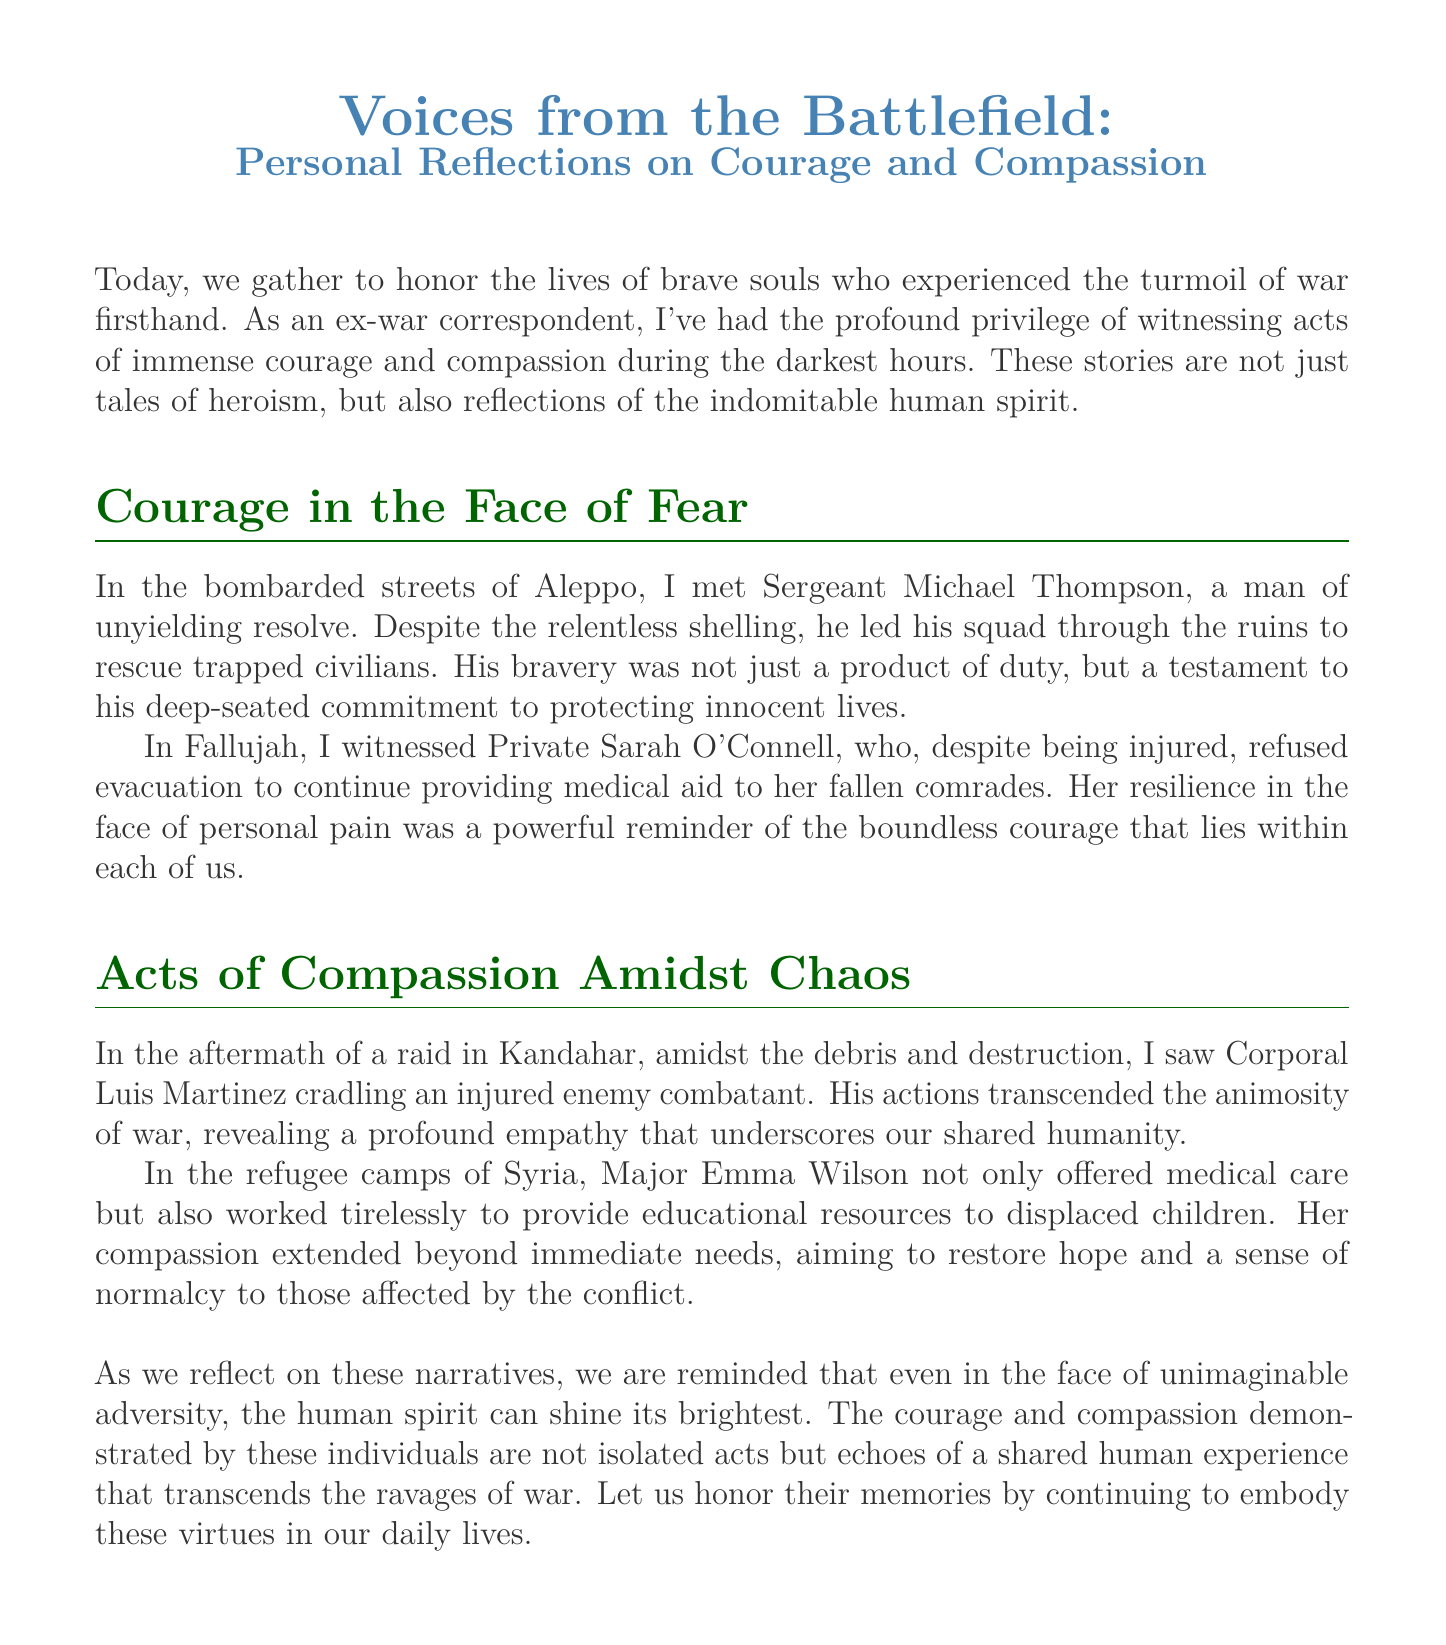What is the title of the document? The title appears prominently at the top of the document, providing the focus of the eulogy.
Answer: Voices from the Battlefield: Personal Reflections on Courage and Compassion Who is mentioned as having unyielding resolve? This name refers to an individual highlighted for their bravery and determination during the conflict described.
Answer: Sergeant Michael Thompson In which location did Sarah O'Connell refuse evacuation? The location indicates where Private Sarah O'Connell demonstrated her commitment to her comrades in need.
Answer: Fallujah What act of compassion did Corporal Luis Martinez perform? The act described illustrates a moment of empathy during the chaos of war, showcasing humanity.
Answer: Cradling an injured enemy combatant What is Major Emma Wilson's contribution beyond medical care? This contribution reflects her understanding of the needs of displaced individuals, beyond just immediate medical assistance.
Answer: Providing educational resources to displaced children What general theme is emphasized throughout the eulogy? This theme indicates the overarching message of the document regarding human character in adversity.
Answer: Courage and compassion 